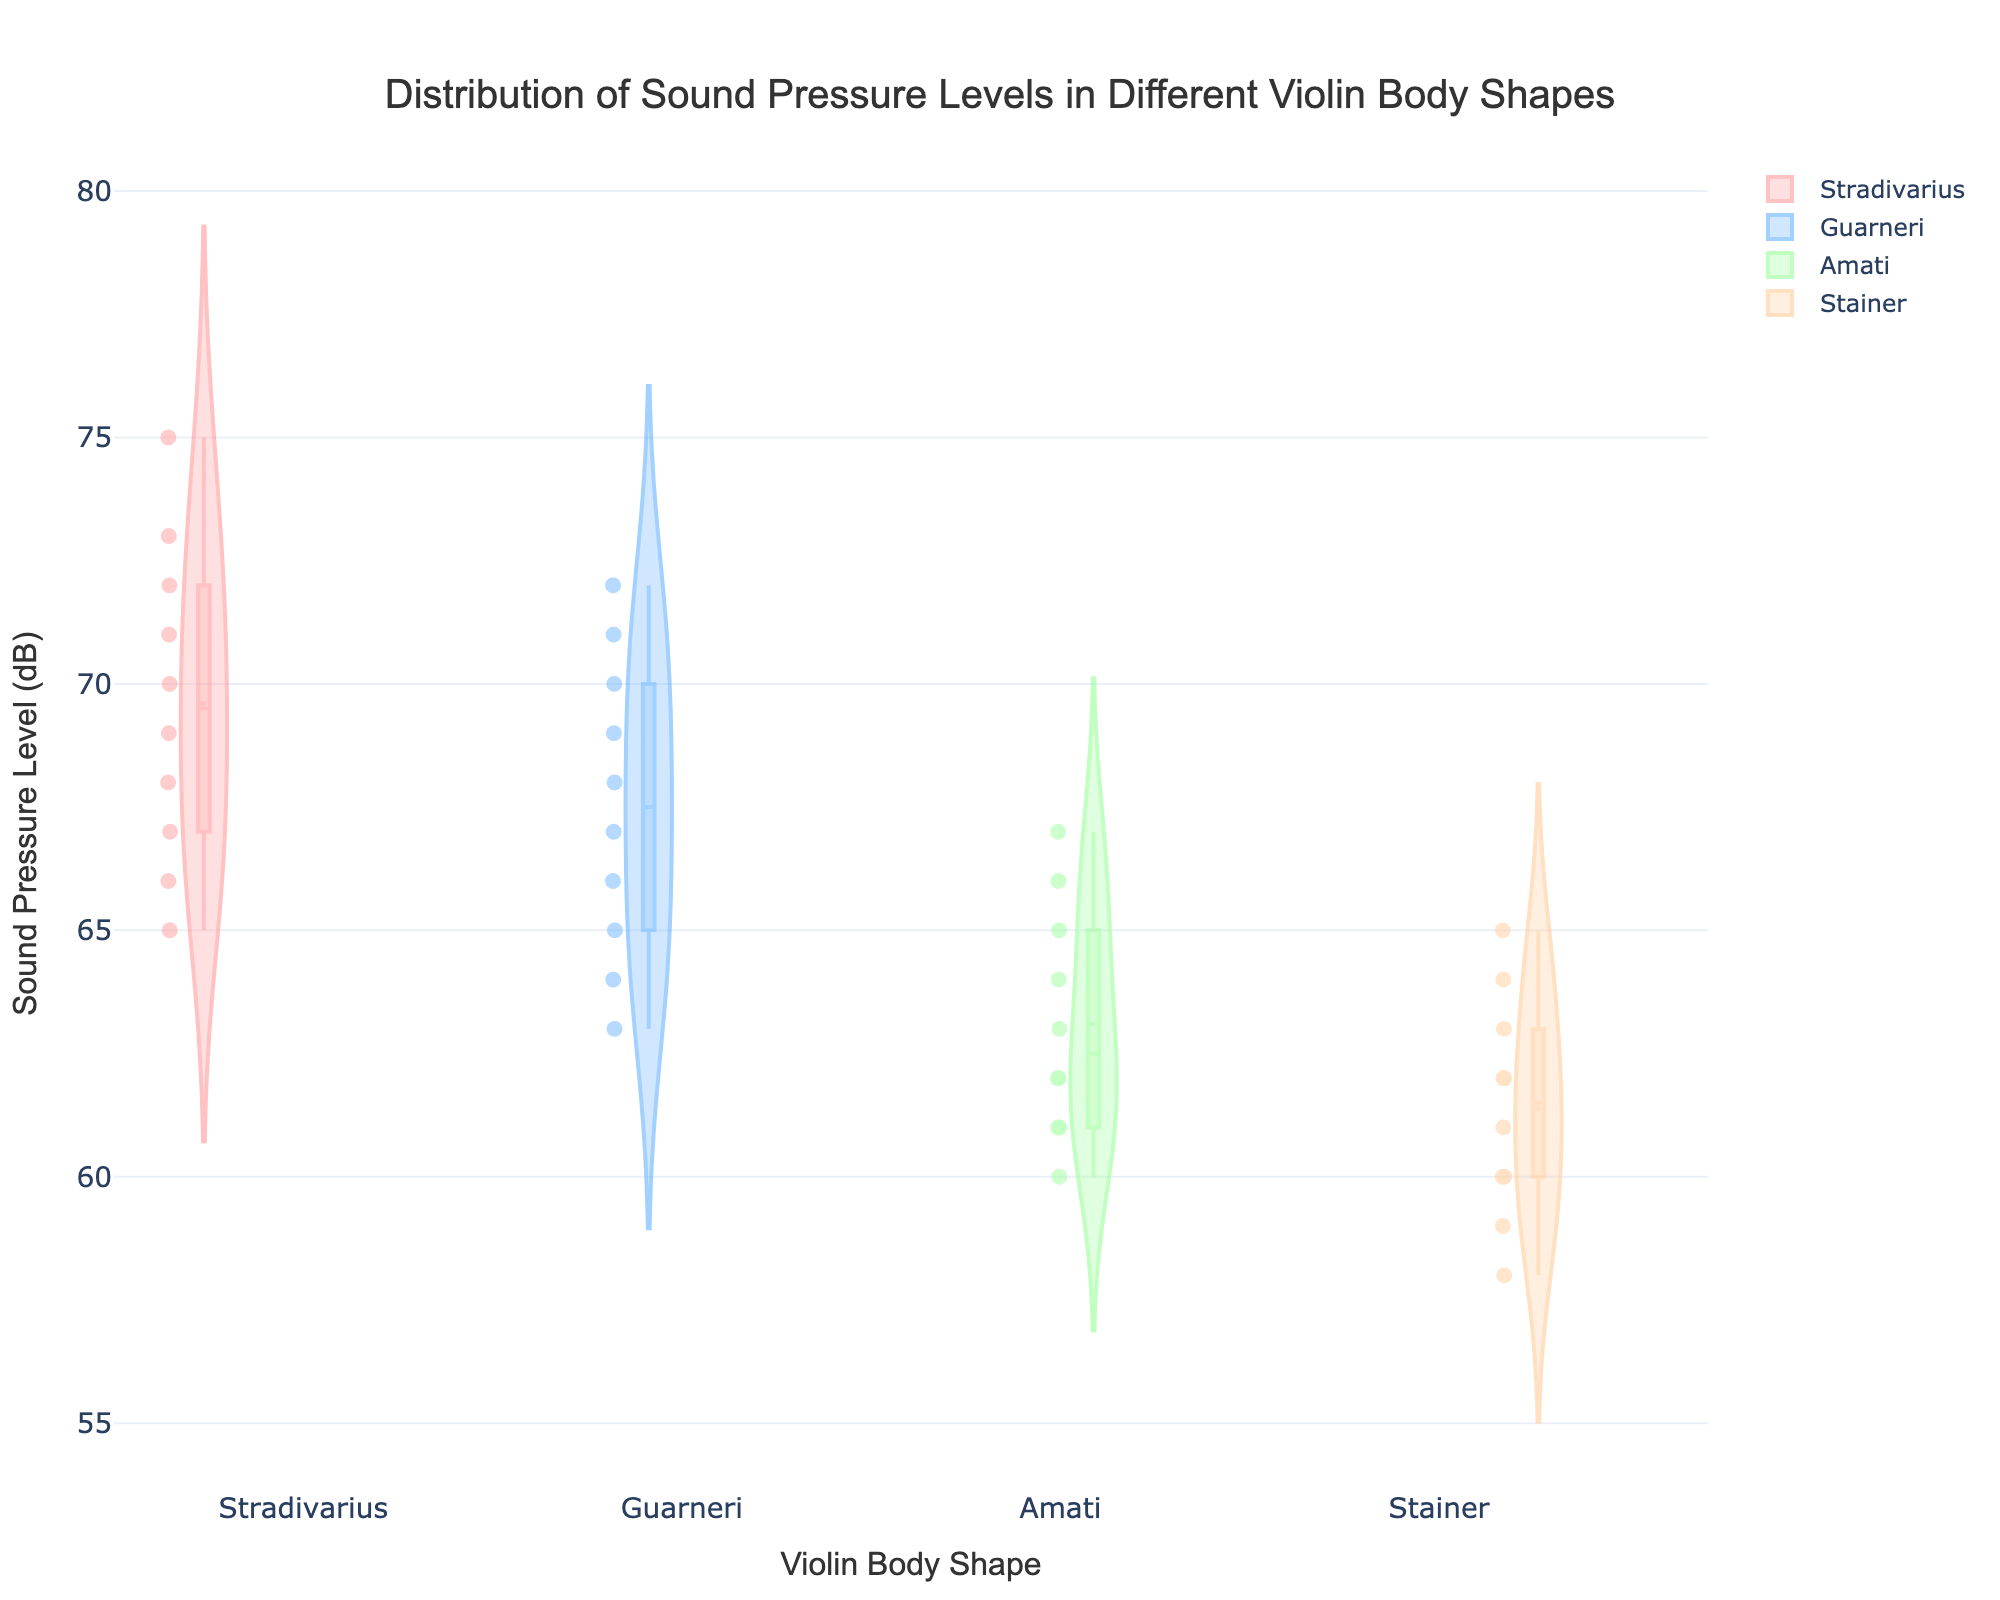What is the title of the figure? The title of the figure is usually displayed at the top of the plot. In this case, the title is "Distribution of Sound Pressure Levels in Different Violin Body Shapes."
Answer: Distribution of Sound Pressure Levels in Different Violin Body Shapes What does the x-axis represent? The x-axis on the plot represents the different shapes of violin bodies. It shows four categories: Stradivarius, Guarneri, Amati, and Stainer.
Answer: Violin Body Shape What does the y-axis represent? The y-axis indicates the sound pressure level measured in decibels (dB). It shows the distribution of sound pressure levels for each violin body shape.
Answer: Sound Pressure Level (dB) Which violin body shape has the highest median sound pressure level? To find the highest median sound pressure level, examine the middle line in each box plot (which is overlaid on the violin plot). The median for Stradivarius appears the highest.
Answer: Stradivarius Which violin body shape has the widest interquartile range (IQR) in sound pressure levels? The IQR is the range between the first quartile (Q1) and the third quartile (Q3) in the box plot. By inspecting the box plots, identify which violin shape has the largest box. Stradivarius appears to have the widest IQR.
Answer: Stradivarius How does the distribution of sound pressure levels in Amati compare to that in Stainer? Compare the entire shape of the violin plots for Amati and Stainer. Amati's distribution is more centered around its median with less spread, while Stainer's distribution is wider with a lower median.
Answer: Amati has a more centered and less spread distribution, Stainer has a wider distribution with a lower median Which violin body shape exhibits the most variability in sound pressure levels? The most variability can be observed by the spread and distribution shapes of the violin plots. Stradivarius has the most spread out points, demonstrating the most variability.
Answer: Stradivarius Which violin body shape has the lowest maximum sound pressure level? Look at the top whisker of the box plots for each violin shape. Stainer has the lowest maximum sound pressure level.
Answer: Stainer Do any violin body shapes share the same median sound pressure level? Compare the median lines (middle lines inside the boxes) of the violin plots. Amati and Stainer appear to have very similar, if not the same, median sound pressure levels.
Answer: Amati and Stainer What is the range of sound pressure levels for Guarneri? The range is determined by the minimum and maximum values in the box plot for Guarneri. The bottom whisker represents the minimum (63 dB) and the top whisker represents the maximum (72 dB), so the range is 72 - 63 = 9 dB.
Answer: 9 dB 